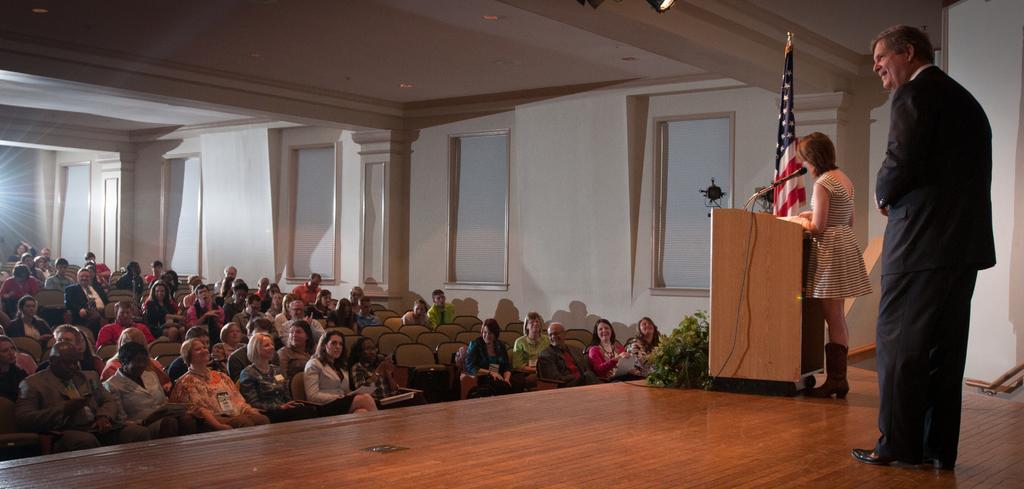Please provide a concise description of this image. In this picture we can see a group of people sitting on chairs and two people are standing on the stage, here we can see a podium, mic, flag, wall, windows, roof and lights. 